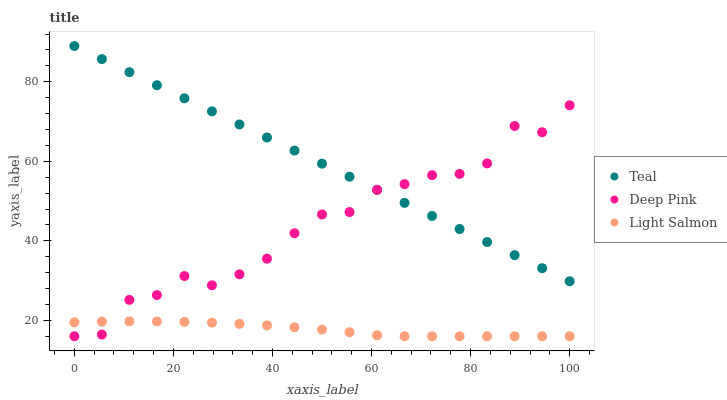Does Light Salmon have the minimum area under the curve?
Answer yes or no. Yes. Does Teal have the maximum area under the curve?
Answer yes or no. Yes. Does Deep Pink have the minimum area under the curve?
Answer yes or no. No. Does Deep Pink have the maximum area under the curve?
Answer yes or no. No. Is Teal the smoothest?
Answer yes or no. Yes. Is Deep Pink the roughest?
Answer yes or no. Yes. Is Deep Pink the smoothest?
Answer yes or no. No. Is Teal the roughest?
Answer yes or no. No. Does Light Salmon have the lowest value?
Answer yes or no. Yes. Does Teal have the lowest value?
Answer yes or no. No. Does Teal have the highest value?
Answer yes or no. Yes. Does Deep Pink have the highest value?
Answer yes or no. No. Is Light Salmon less than Teal?
Answer yes or no. Yes. Is Teal greater than Light Salmon?
Answer yes or no. Yes. Does Deep Pink intersect Light Salmon?
Answer yes or no. Yes. Is Deep Pink less than Light Salmon?
Answer yes or no. No. Is Deep Pink greater than Light Salmon?
Answer yes or no. No. Does Light Salmon intersect Teal?
Answer yes or no. No. 